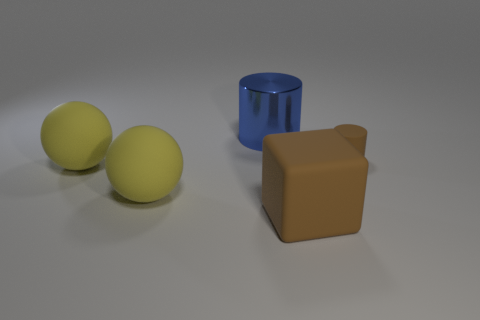Is there anything else that is the same size as the rubber cylinder?
Your answer should be very brief. No. Are there any other things that are made of the same material as the large blue cylinder?
Give a very brief answer. No. Does the tiny brown object have the same shape as the blue shiny thing?
Keep it short and to the point. Yes. There is a matte object that is to the right of the large matte thing that is on the right side of the cylinder that is behind the brown cylinder; what color is it?
Offer a terse response. Brown. What number of blue shiny objects have the same shape as the small brown matte object?
Give a very brief answer. 1. How big is the cylinder that is in front of the cylinder to the left of the big brown matte object?
Ensure brevity in your answer.  Small. Is the size of the brown matte block the same as the blue cylinder?
Make the answer very short. Yes. There is a cylinder that is on the left side of the large thing on the right side of the blue cylinder; are there any big brown rubber things behind it?
Your response must be concise. No. What is the size of the brown cube?
Offer a very short reply. Large. What number of other brown matte cylinders have the same size as the brown matte cylinder?
Your response must be concise. 0. 